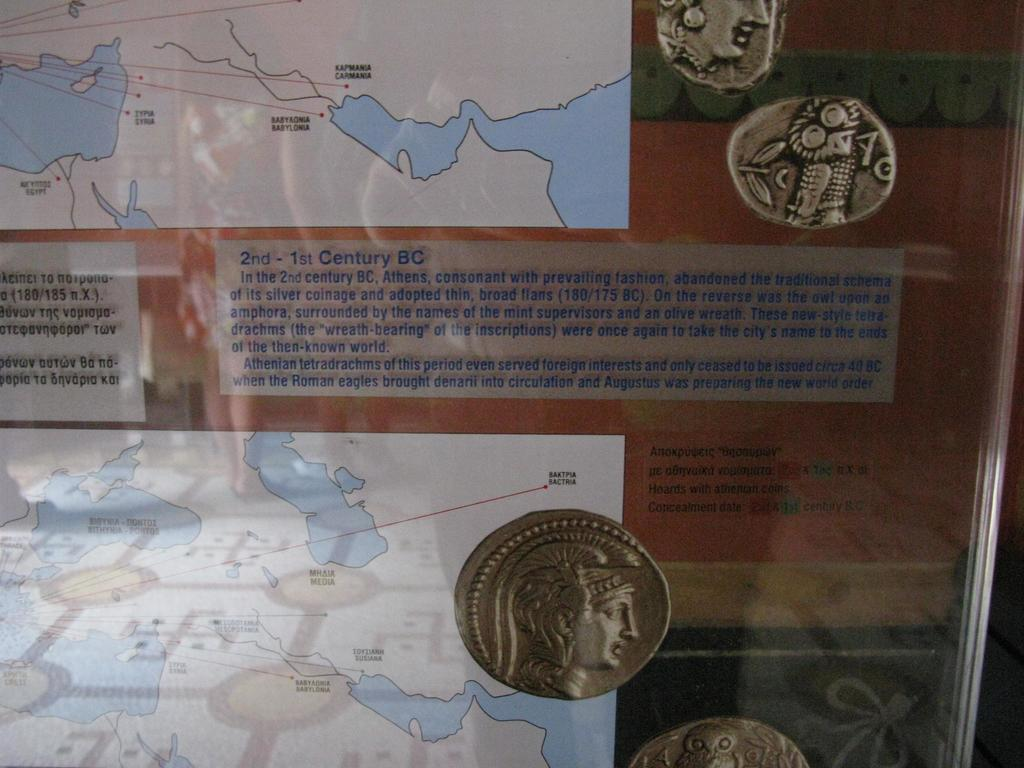<image>
Summarize the visual content of the image. The writing on the image supports 1st Centuty BC 